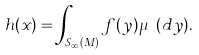<formula> <loc_0><loc_0><loc_500><loc_500>h ( x ) = \int _ { S _ { \infty } ( M ) } f ( y ) \mu _ { x } ( d y ) .</formula> 